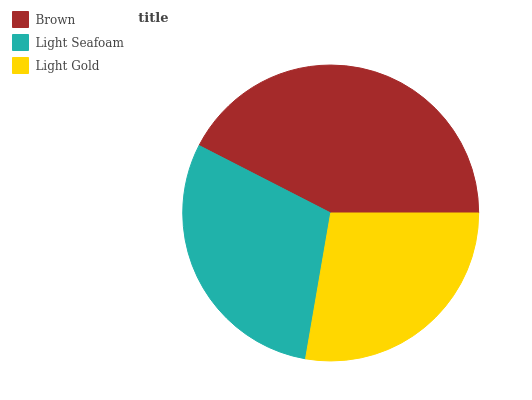Is Light Gold the minimum?
Answer yes or no. Yes. Is Brown the maximum?
Answer yes or no. Yes. Is Light Seafoam the minimum?
Answer yes or no. No. Is Light Seafoam the maximum?
Answer yes or no. No. Is Brown greater than Light Seafoam?
Answer yes or no. Yes. Is Light Seafoam less than Brown?
Answer yes or no. Yes. Is Light Seafoam greater than Brown?
Answer yes or no. No. Is Brown less than Light Seafoam?
Answer yes or no. No. Is Light Seafoam the high median?
Answer yes or no. Yes. Is Light Seafoam the low median?
Answer yes or no. Yes. Is Brown the high median?
Answer yes or no. No. Is Light Gold the low median?
Answer yes or no. No. 